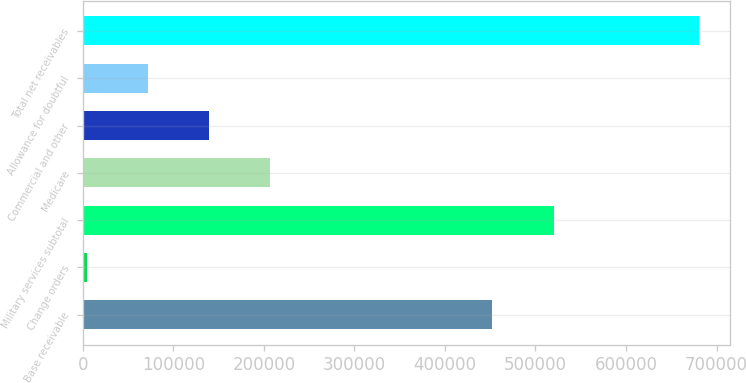Convert chart to OTSL. <chart><loc_0><loc_0><loc_500><loc_500><bar_chart><fcel>Base receivable<fcel>Change orders<fcel>Military services subtotal<fcel>Medicare<fcel>Commercial and other<fcel>Allowance for doubtful<fcel>Total net receivables<nl><fcel>452509<fcel>4247<fcel>520178<fcel>207255<fcel>139586<fcel>71916.4<fcel>680941<nl></chart> 